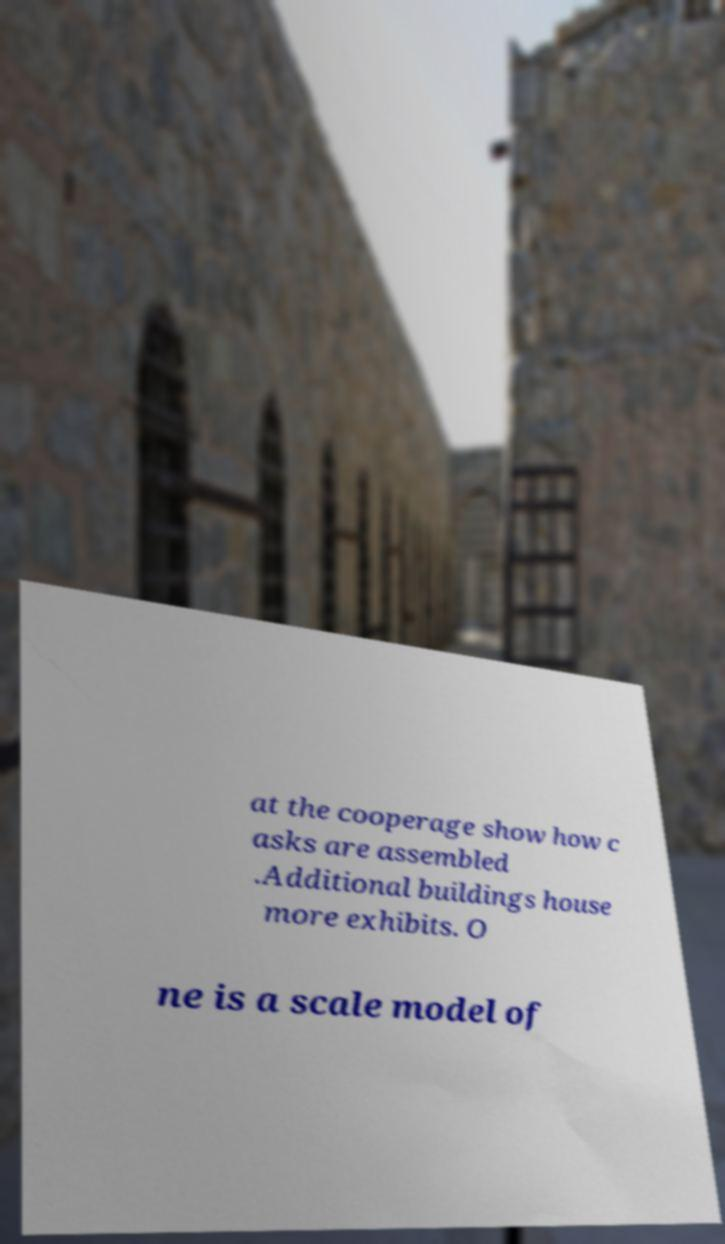Can you accurately transcribe the text from the provided image for me? at the cooperage show how c asks are assembled .Additional buildings house more exhibits. O ne is a scale model of 